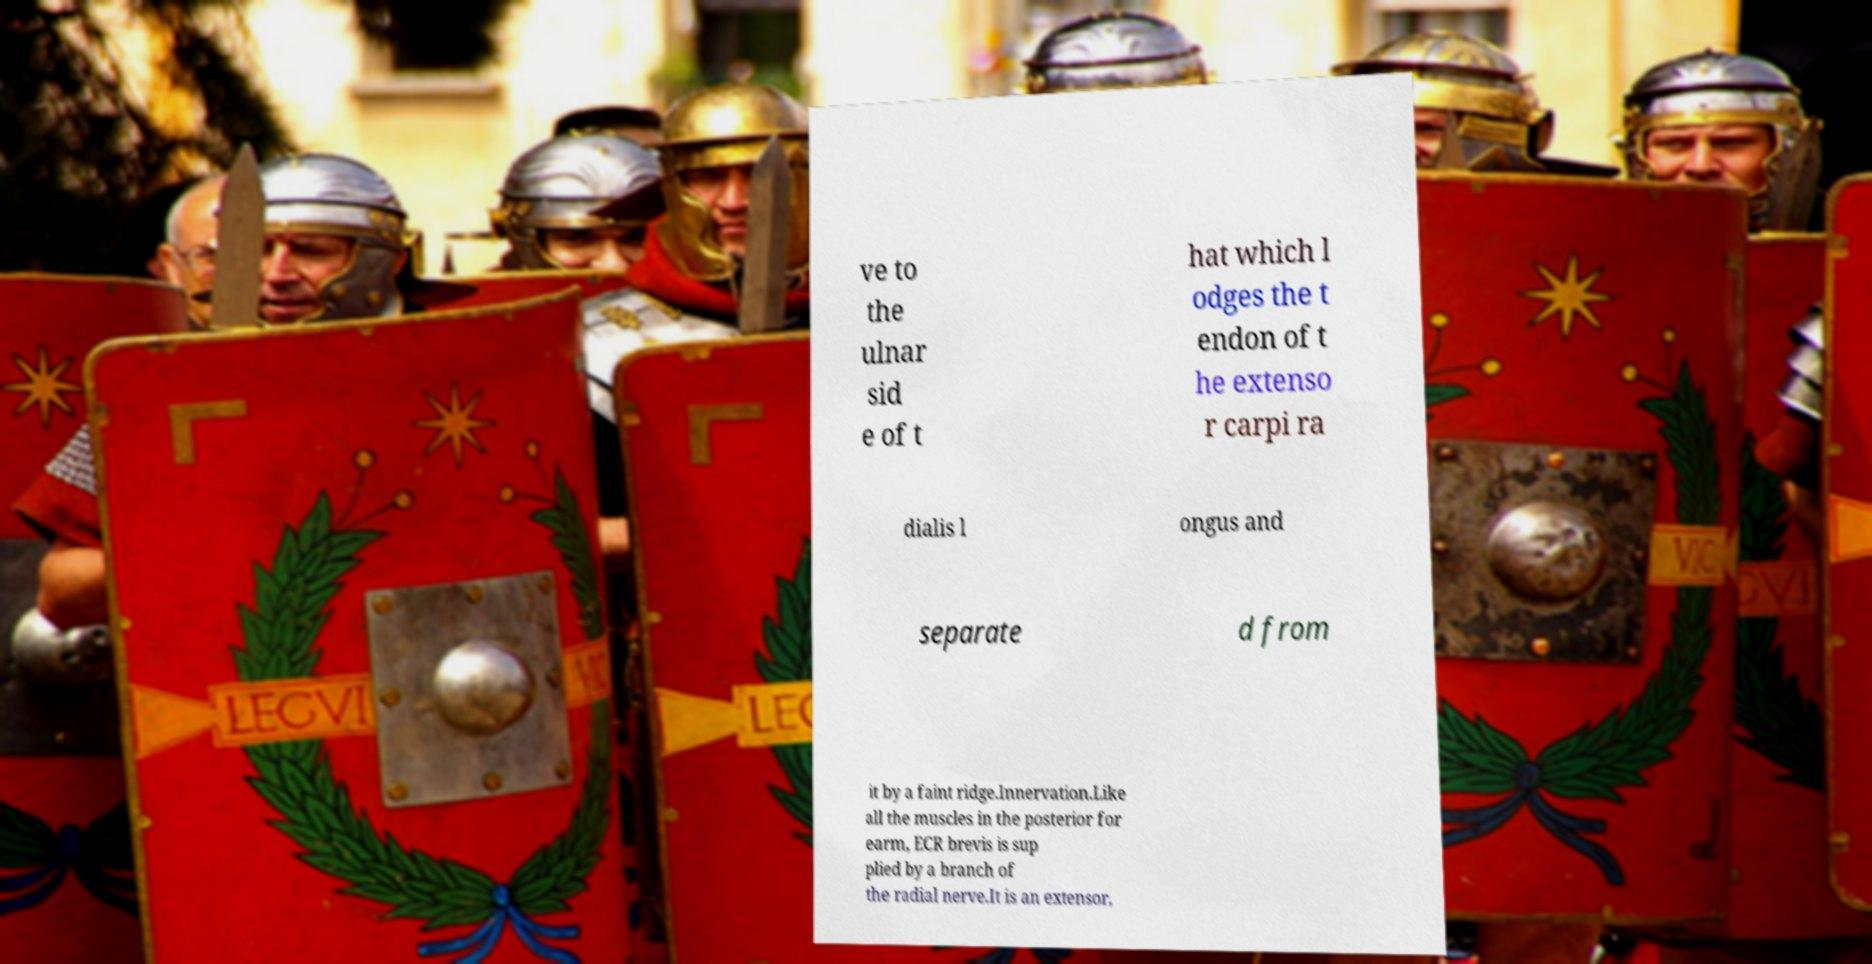Could you extract and type out the text from this image? ve to the ulnar sid e of t hat which l odges the t endon of t he extenso r carpi ra dialis l ongus and separate d from it by a faint ridge.Innervation.Like all the muscles in the posterior for earm, ECR brevis is sup plied by a branch of the radial nerve.It is an extensor, 